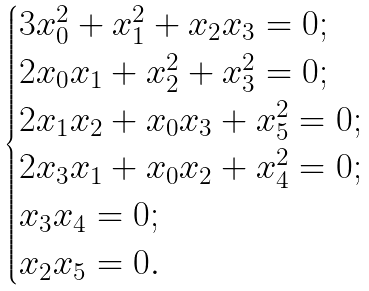Convert formula to latex. <formula><loc_0><loc_0><loc_500><loc_500>\begin{cases} 3 x _ { 0 } ^ { 2 } + x _ { 1 } ^ { 2 } + x _ { 2 } x _ { 3 } = 0 ; \\ 2 x _ { 0 } x _ { 1 } + x _ { 2 } ^ { 2 } + x _ { 3 } ^ { 2 } = 0 ; \\ 2 x _ { 1 } x _ { 2 } + x _ { 0 } x _ { 3 } + x _ { 5 } ^ { 2 } = 0 ; \\ 2 x _ { 3 } x _ { 1 } + x _ { 0 } x _ { 2 } + x _ { 4 } ^ { 2 } = 0 ; \\ x _ { 3 } x _ { 4 } = 0 ; \\ x _ { 2 } x _ { 5 } = 0 . \end{cases}</formula> 